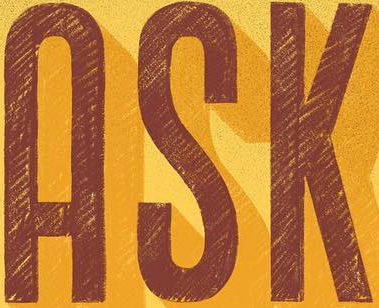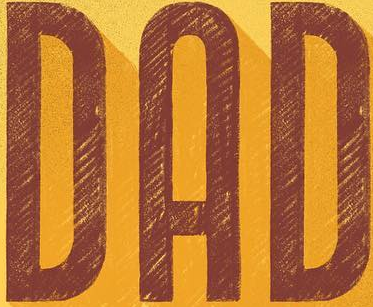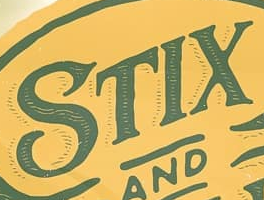Identify the words shown in these images in order, separated by a semicolon. ASK; DAD; STIX 